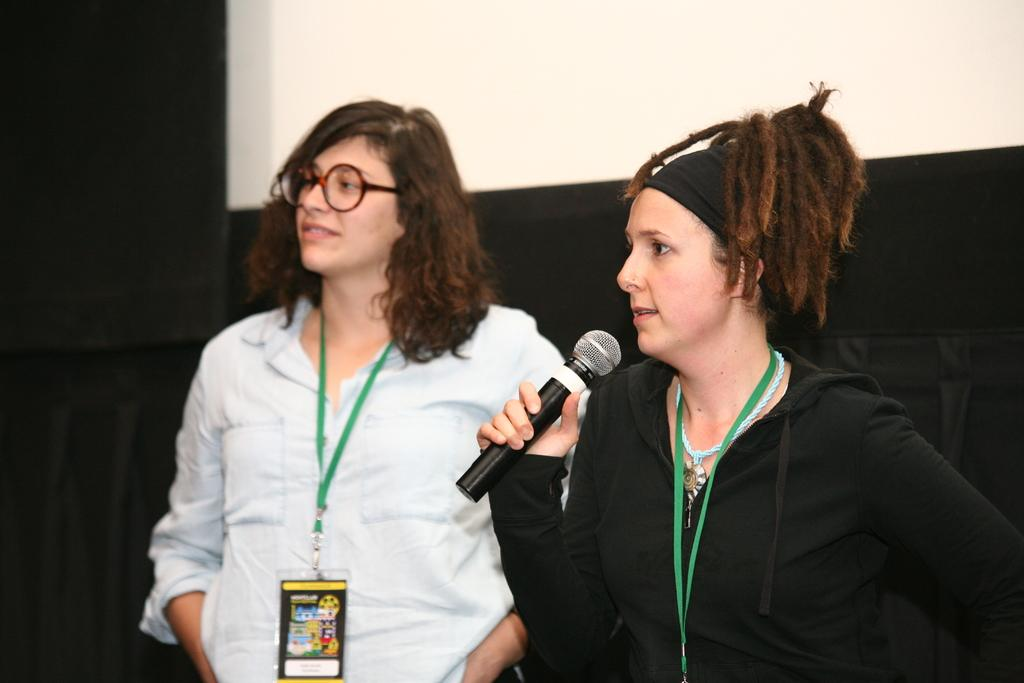What is the main subject on the right side of the image? There is a woman on the right side of the image. What is the woman on the right holding in her hand? The woman on the right is holding a mic in her hand. Can you describe the positioning of the other woman in the image? There is another woman standing beside the woman on the right. What type of calendar is visible on the wall behind the women? There is no calendar visible in the image. What is the nature of the argument between the two women in the image? There is no argument between the two women in the image; they are simply standing beside each other. 